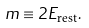Convert formula to latex. <formula><loc_0><loc_0><loc_500><loc_500>m \equiv 2 E _ { \text {rest} } .</formula> 